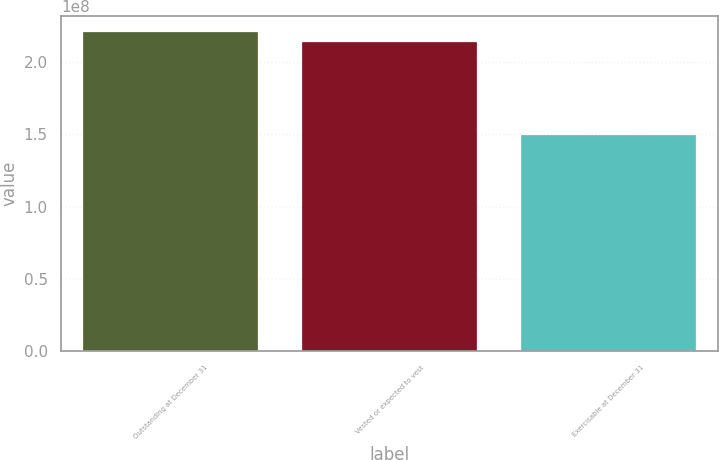<chart> <loc_0><loc_0><loc_500><loc_500><bar_chart><fcel>Outstanding at December 31<fcel>Vested or expected to vest<fcel>Exercisable at December 31<nl><fcel>2.20953e+08<fcel>2.14137e+08<fcel>1.49788e+08<nl></chart> 